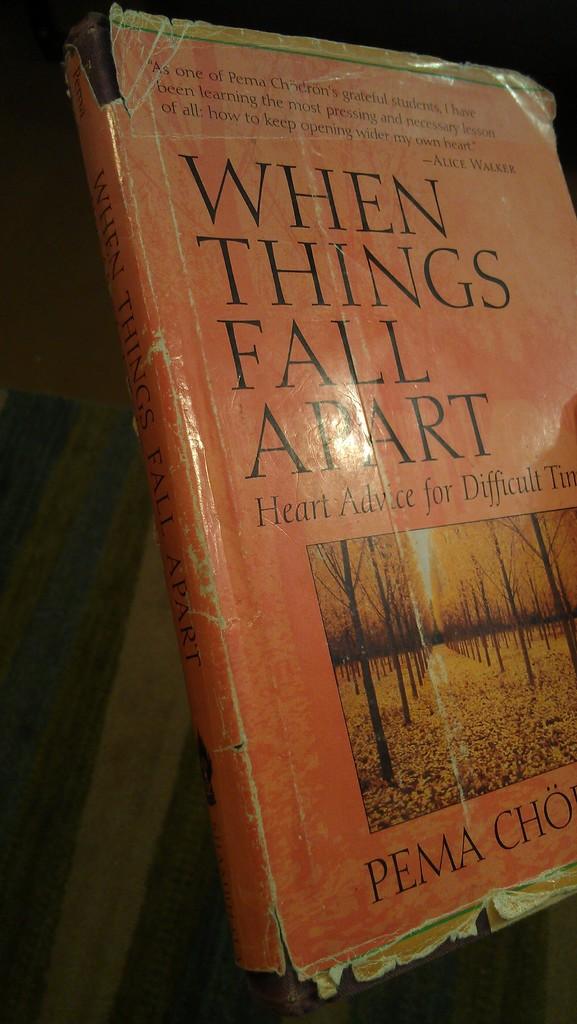What do things do?
Keep it short and to the point. Fall apart. What is the rest of the last name of the author pema?
Offer a terse response. Cho. 